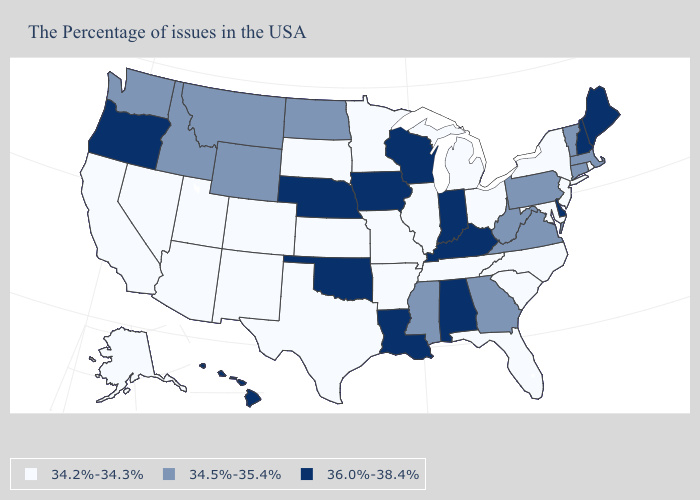What is the value of Rhode Island?
Write a very short answer. 34.2%-34.3%. Name the states that have a value in the range 34.5%-35.4%?
Write a very short answer. Massachusetts, Vermont, Connecticut, Pennsylvania, Virginia, West Virginia, Georgia, Mississippi, North Dakota, Wyoming, Montana, Idaho, Washington. Does Kansas have the lowest value in the USA?
Quick response, please. Yes. What is the value of Massachusetts?
Short answer required. 34.5%-35.4%. What is the highest value in the West ?
Concise answer only. 36.0%-38.4%. What is the highest value in the MidWest ?
Short answer required. 36.0%-38.4%. Which states have the highest value in the USA?
Concise answer only. Maine, New Hampshire, Delaware, Kentucky, Indiana, Alabama, Wisconsin, Louisiana, Iowa, Nebraska, Oklahoma, Oregon, Hawaii. Does Hawaii have the lowest value in the West?
Concise answer only. No. Does Idaho have the lowest value in the West?
Give a very brief answer. No. Name the states that have a value in the range 34.5%-35.4%?
Keep it brief. Massachusetts, Vermont, Connecticut, Pennsylvania, Virginia, West Virginia, Georgia, Mississippi, North Dakota, Wyoming, Montana, Idaho, Washington. What is the highest value in states that border Pennsylvania?
Write a very short answer. 36.0%-38.4%. What is the value of Pennsylvania?
Quick response, please. 34.5%-35.4%. What is the lowest value in the Northeast?
Keep it brief. 34.2%-34.3%. Among the states that border Iowa , which have the highest value?
Answer briefly. Wisconsin, Nebraska. Does West Virginia have a lower value than New Jersey?
Give a very brief answer. No. 